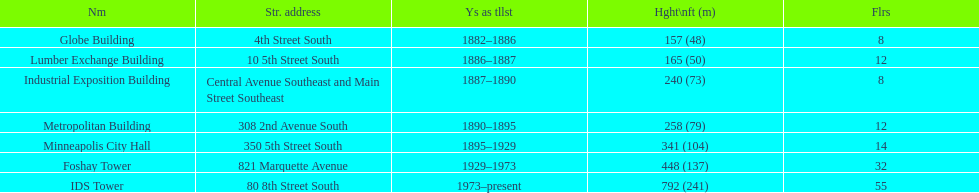How tall is it to the top of the ids tower in feet? 792. 